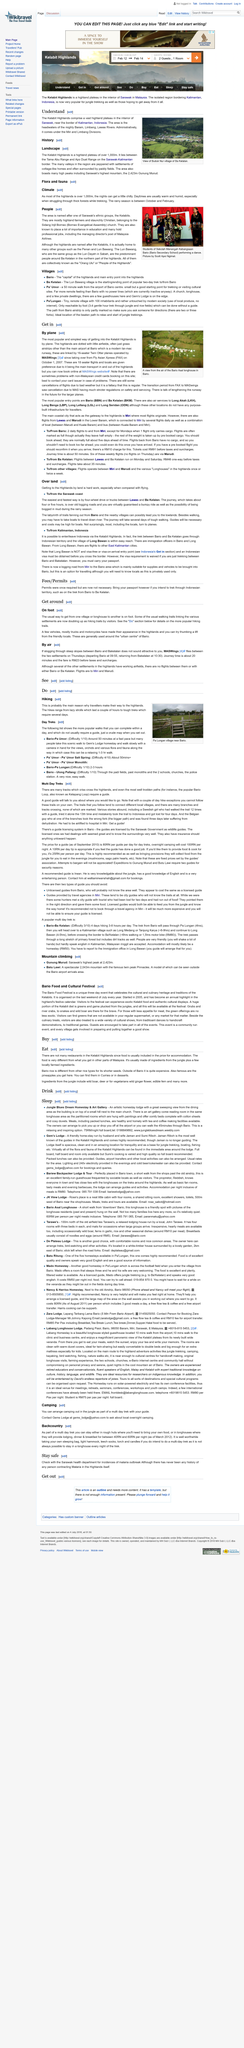Specify some key components in this picture. The ground level at the Kelabit Highlands is over 1,000 meters. The location of the Buduk Nur village is Ba Kelalan. Gunung Murud is the highest mountain in Sarawak. 